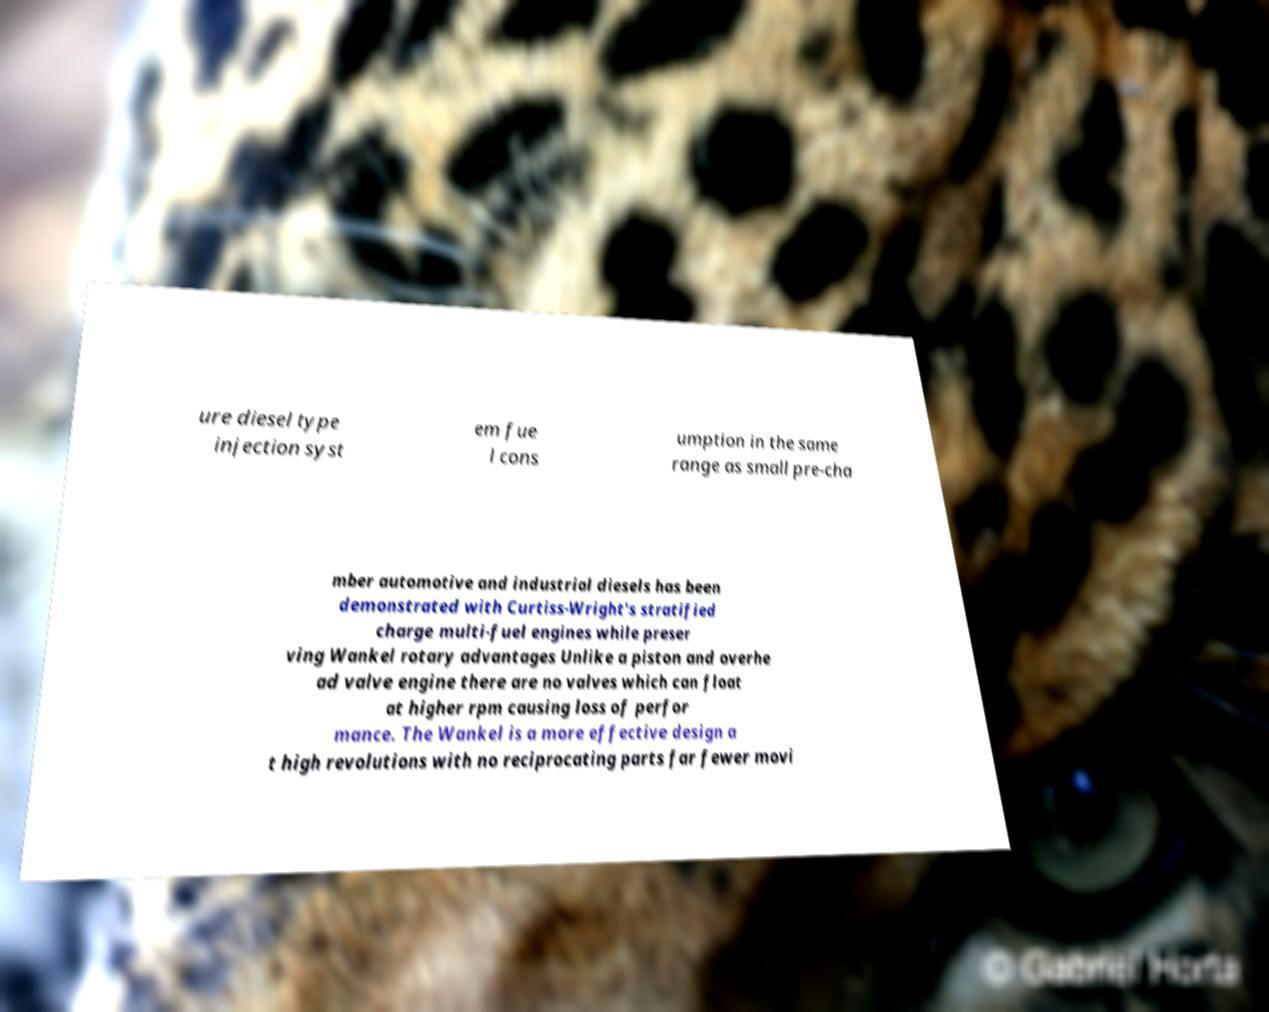Could you assist in decoding the text presented in this image and type it out clearly? ure diesel type injection syst em fue l cons umption in the same range as small pre-cha mber automotive and industrial diesels has been demonstrated with Curtiss-Wright's stratified charge multi-fuel engines while preser ving Wankel rotary advantages Unlike a piston and overhe ad valve engine there are no valves which can float at higher rpm causing loss of perfor mance. The Wankel is a more effective design a t high revolutions with no reciprocating parts far fewer movi 